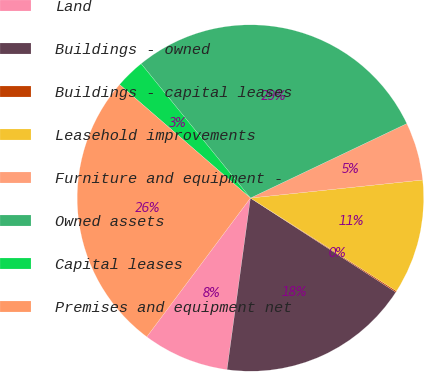<chart> <loc_0><loc_0><loc_500><loc_500><pie_chart><fcel>Land<fcel>Buildings - owned<fcel>Buildings - capital leases<fcel>Leasehold improvements<fcel>Furniture and equipment -<fcel>Owned assets<fcel>Capital leases<fcel>Premises and equipment net<nl><fcel>8.05%<fcel>18.01%<fcel>0.12%<fcel>10.69%<fcel>5.41%<fcel>28.8%<fcel>2.76%<fcel>26.16%<nl></chart> 